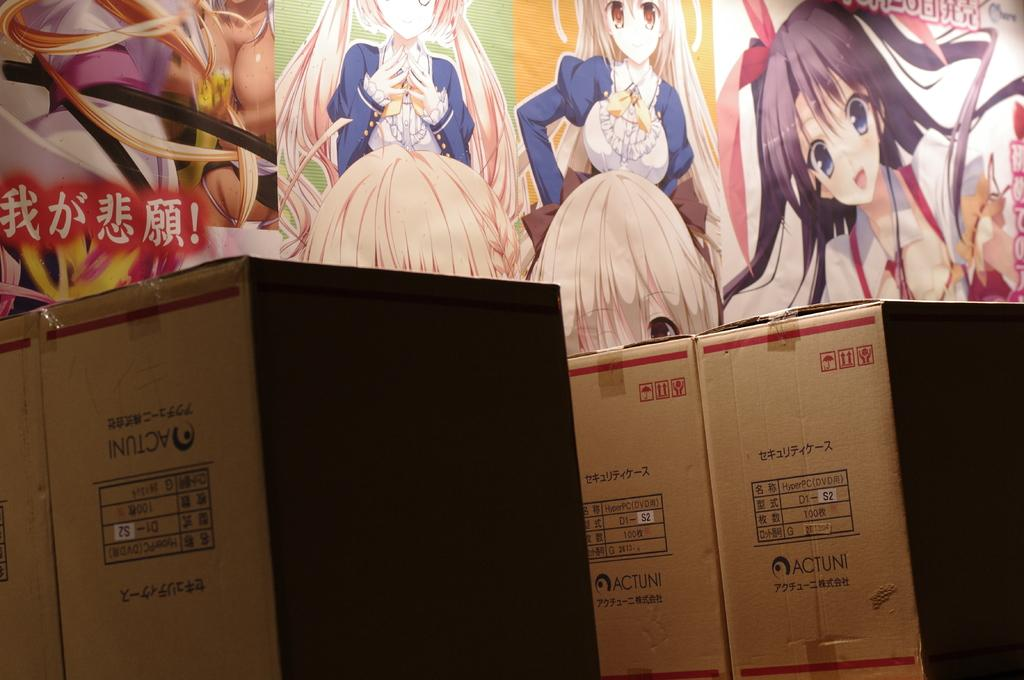What objects are located at the bottom of the image? There are cardboard boxes at the bottom of the image. What can be seen behind the boxes in the image? There is a wall with paintings behind the boxes. How many boats are visible in the image? There are no boats present in the image. What type of horse is depicted in the painting on the wall? There is no horse depicted in the painting on the wall; the paintings cannot be identified in the image. 